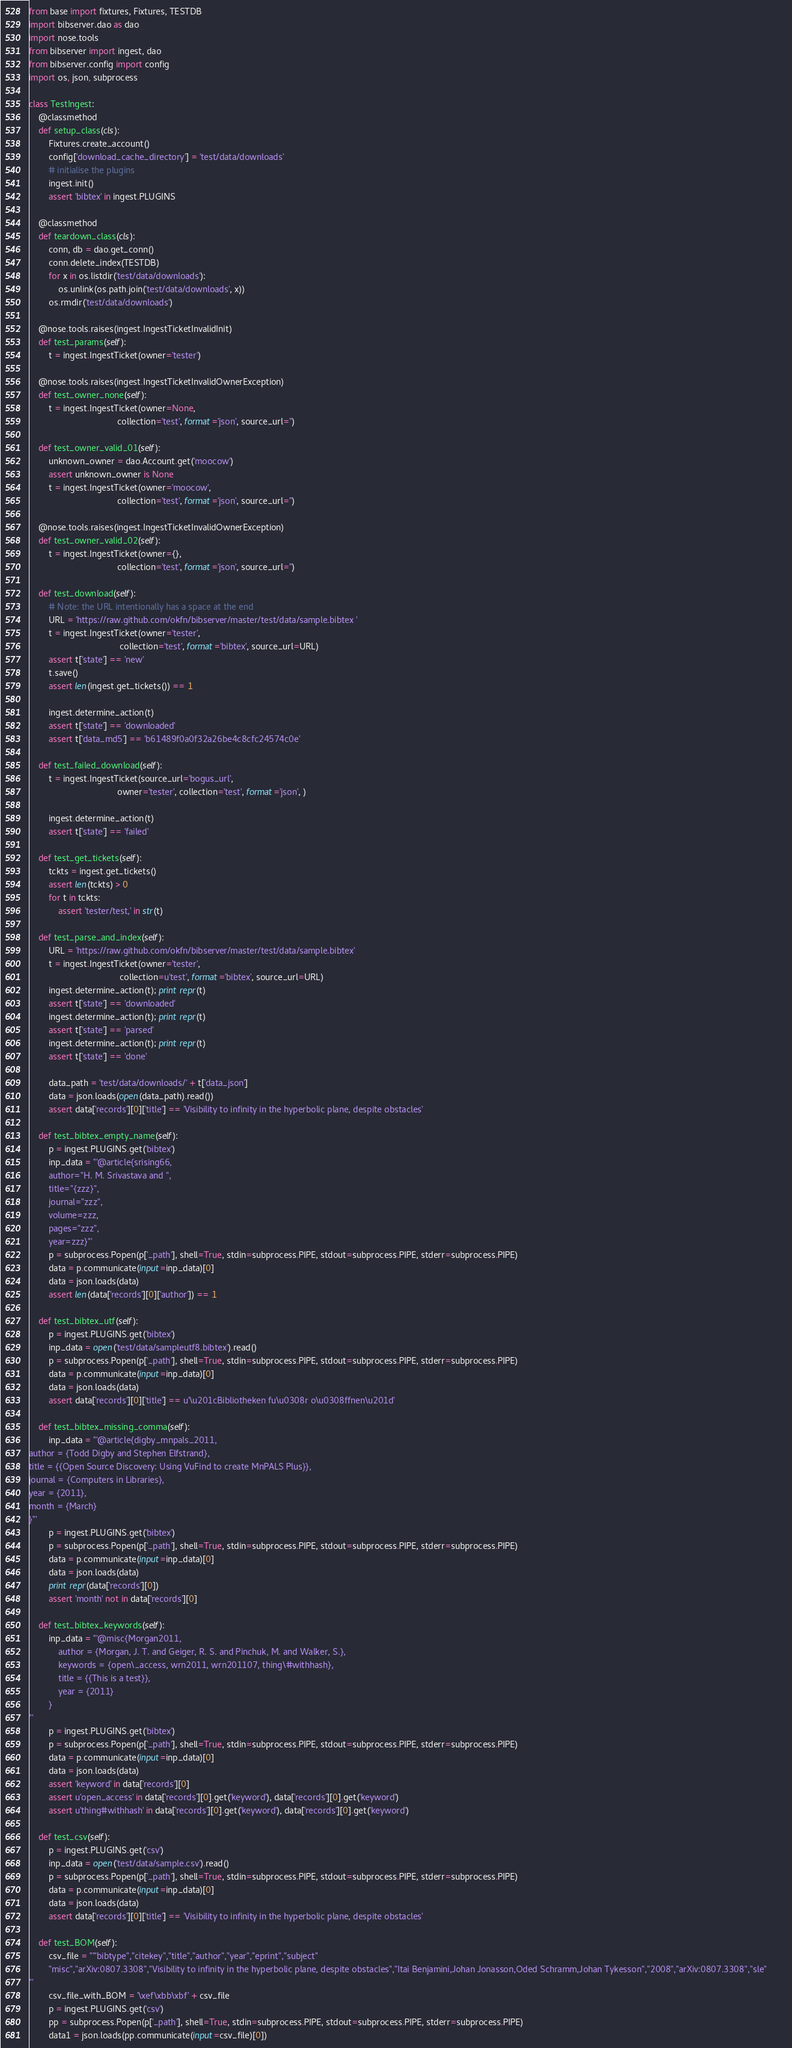Convert code to text. <code><loc_0><loc_0><loc_500><loc_500><_Python_>from base import fixtures, Fixtures, TESTDB
import bibserver.dao as dao
import nose.tools
from bibserver import ingest, dao
from bibserver.config import config
import os, json, subprocess

class TestIngest:
    @classmethod
    def setup_class(cls):
        Fixtures.create_account()
        config['download_cache_directory'] = 'test/data/downloads'
        # initialise the plugins
        ingest.init()
        assert 'bibtex' in ingest.PLUGINS

    @classmethod
    def teardown_class(cls):
        conn, db = dao.get_conn()
        conn.delete_index(TESTDB)
        for x in os.listdir('test/data/downloads'):
            os.unlink(os.path.join('test/data/downloads', x))
        os.rmdir('test/data/downloads')

    @nose.tools.raises(ingest.IngestTicketInvalidInit)
    def test_params(self):
        t = ingest.IngestTicket(owner='tester')

    @nose.tools.raises(ingest.IngestTicketInvalidOwnerException)
    def test_owner_none(self):
        t = ingest.IngestTicket(owner=None, 
                                    collection='test', format='json', source_url='')

    def test_owner_valid_01(self):
        unknown_owner = dao.Account.get('moocow')
        assert unknown_owner is None
        t = ingest.IngestTicket(owner='moocow',
                                    collection='test', format='json', source_url='')

    @nose.tools.raises(ingest.IngestTicketInvalidOwnerException)
    def test_owner_valid_02(self):
        t = ingest.IngestTicket(owner={}, 
                                    collection='test', format='json', source_url='')

    def test_download(self):
        # Note: the URL intentionally has a space at the end
        URL = 'https://raw.github.com/okfn/bibserver/master/test/data/sample.bibtex '
        t = ingest.IngestTicket(owner='tester', 
                                     collection='test', format='bibtex', source_url=URL)
        assert t['state'] == 'new'
        t.save()
        assert len(ingest.get_tickets()) == 1
        
        ingest.determine_action(t)
        assert t['state'] == 'downloaded'
        assert t['data_md5'] == 'b61489f0a0f32a26be4c8cfc24574c0e'

    def test_failed_download(self):
        t = ingest.IngestTicket(source_url='bogus_url',
                                    owner='tester', collection='test', format='json', )
        
        ingest.determine_action(t)
        assert t['state'] == 'failed'
        
    def test_get_tickets(self):
        tckts = ingest.get_tickets()
        assert len(tckts) > 0
        for t in tckts:
            assert 'tester/test,' in str(t)

    def test_parse_and_index(self):
        URL = 'https://raw.github.com/okfn/bibserver/master/test/data/sample.bibtex'
        t = ingest.IngestTicket(owner='tester', 
                                     collection=u'test', format='bibtex', source_url=URL)
        ingest.determine_action(t); print repr(t)
        assert t['state'] == 'downloaded'
        ingest.determine_action(t); print repr(t)
        assert t['state'] == 'parsed'
        ingest.determine_action(t); print repr(t)
        assert t['state'] == 'done'
        
        data_path = 'test/data/downloads/' + t['data_json']
        data = json.loads(open(data_path).read())
        assert data['records'][0]['title'] == 'Visibility to infinity in the hyperbolic plane, despite obstacles'
        
    def test_bibtex_empty_name(self):
        p = ingest.PLUGINS.get('bibtex')
        inp_data = '''@article{srising66,
        author="H. M. Srivastava and ",
        title="{zzz}",
        journal="zzz",
        volume=zzz,
        pages="zzz",
        year=zzz}'''
        p = subprocess.Popen(p['_path'], shell=True, stdin=subprocess.PIPE, stdout=subprocess.PIPE, stderr=subprocess.PIPE)
        data = p.communicate(input=inp_data)[0]
        data = json.loads(data)
        assert len(data['records'][0]['author']) == 1
        
    def test_bibtex_utf(self):
        p = ingest.PLUGINS.get('bibtex')
        inp_data = open('test/data/sampleutf8.bibtex').read()
        p = subprocess.Popen(p['_path'], shell=True, stdin=subprocess.PIPE, stdout=subprocess.PIPE, stderr=subprocess.PIPE)
        data = p.communicate(input=inp_data)[0]
        data = json.loads(data)
        assert data['records'][0]['title'] == u'\u201cBibliotheken fu\u0308r o\u0308ffnen\u201d'

    def test_bibtex_missing_comma(self):
        inp_data = '''@article{digby_mnpals_2011,
author = {Todd Digby and Stephen Elfstrand},
title = {{Open Source Discovery: Using VuFind to create MnPALS Plus}},
journal = {Computers in Libraries},
year = {2011},
month = {March}
}'''
        p = ingest.PLUGINS.get('bibtex')
        p = subprocess.Popen(p['_path'], shell=True, stdin=subprocess.PIPE, stdout=subprocess.PIPE, stderr=subprocess.PIPE)
        data = p.communicate(input=inp_data)[0]
        data = json.loads(data)
        print repr(data['records'][0])
        assert 'month' not in data['records'][0]

    def test_bibtex_keywords(self):
        inp_data = '''@misc{Morgan2011,
            author = {Morgan, J. T. and Geiger, R. S. and Pinchuk, M. and Walker, S.},
            keywords = {open\_access, wrn2011, wrn201107, thing\#withhash},
            title = {{This is a test}},
            year = {2011}
        }
'''
        p = ingest.PLUGINS.get('bibtex')
        p = subprocess.Popen(p['_path'], shell=True, stdin=subprocess.PIPE, stdout=subprocess.PIPE, stderr=subprocess.PIPE)
        data = p.communicate(input=inp_data)[0]
        data = json.loads(data)
        assert 'keyword' in data['records'][0]
        assert u'open_access' in data['records'][0].get('keyword'), data['records'][0].get('keyword')
        assert u'thing#withhash' in data['records'][0].get('keyword'), data['records'][0].get('keyword')

    def test_csv(self):
        p = ingest.PLUGINS.get('csv')
        inp_data = open('test/data/sample.csv').read()
        p = subprocess.Popen(p['_path'], shell=True, stdin=subprocess.PIPE, stdout=subprocess.PIPE, stderr=subprocess.PIPE)
        data = p.communicate(input=inp_data)[0]
        data = json.loads(data)
        assert data['records'][0]['title'] == 'Visibility to infinity in the hyperbolic plane, despite obstacles'

    def test_BOM(self):
        csv_file = '''"bibtype","citekey","title","author","year","eprint","subject"
        "misc","arXiv:0807.3308","Visibility to infinity in the hyperbolic plane, despite obstacles","Itai Benjamini,Johan Jonasson,Oded Schramm,Johan Tykesson","2008","arXiv:0807.3308","sle"        
'''
        csv_file_with_BOM = '\xef\xbb\xbf' + csv_file
        p = ingest.PLUGINS.get('csv')
        pp = subprocess.Popen(p['_path'], shell=True, stdin=subprocess.PIPE, stdout=subprocess.PIPE, stderr=subprocess.PIPE)
        data1 = json.loads(pp.communicate(input=csv_file)[0])</code> 